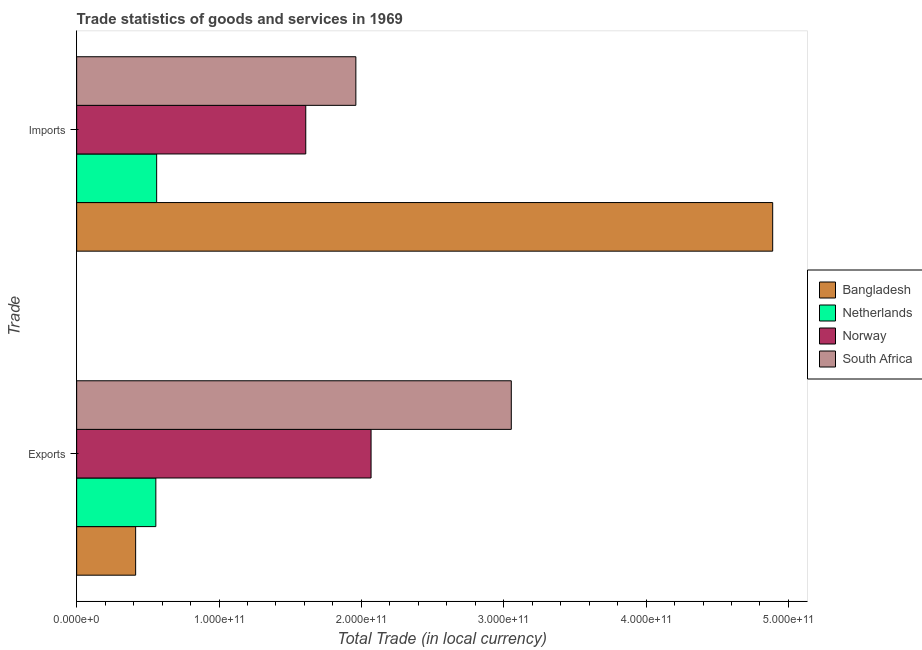How many different coloured bars are there?
Your answer should be compact. 4. What is the label of the 1st group of bars from the top?
Your response must be concise. Imports. What is the export of goods and services in Norway?
Keep it short and to the point. 2.07e+11. Across all countries, what is the maximum imports of goods and services?
Provide a short and direct response. 4.89e+11. Across all countries, what is the minimum imports of goods and services?
Your answer should be compact. 5.62e+1. In which country was the imports of goods and services maximum?
Keep it short and to the point. Bangladesh. In which country was the export of goods and services minimum?
Offer a terse response. Bangladesh. What is the total imports of goods and services in the graph?
Give a very brief answer. 9.02e+11. What is the difference between the imports of goods and services in Bangladesh and that in Netherlands?
Your response must be concise. 4.33e+11. What is the difference between the export of goods and services in Norway and the imports of goods and services in Bangladesh?
Your response must be concise. -2.82e+11. What is the average imports of goods and services per country?
Your response must be concise. 2.26e+11. What is the difference between the export of goods and services and imports of goods and services in Bangladesh?
Offer a very short reply. -4.48e+11. What is the ratio of the imports of goods and services in Norway to that in Netherlands?
Your answer should be very brief. 2.86. Is the export of goods and services in South Africa less than that in Bangladesh?
Keep it short and to the point. No. In how many countries, is the export of goods and services greater than the average export of goods and services taken over all countries?
Provide a short and direct response. 2. How many bars are there?
Give a very brief answer. 8. Are all the bars in the graph horizontal?
Your answer should be compact. Yes. What is the difference between two consecutive major ticks on the X-axis?
Make the answer very short. 1.00e+11. How many legend labels are there?
Your answer should be compact. 4. How are the legend labels stacked?
Your answer should be compact. Vertical. What is the title of the graph?
Your response must be concise. Trade statistics of goods and services in 1969. What is the label or title of the X-axis?
Your answer should be compact. Total Trade (in local currency). What is the label or title of the Y-axis?
Give a very brief answer. Trade. What is the Total Trade (in local currency) of Bangladesh in Exports?
Offer a very short reply. 4.14e+1. What is the Total Trade (in local currency) of Netherlands in Exports?
Give a very brief answer. 5.56e+1. What is the Total Trade (in local currency) in Norway in Exports?
Your answer should be very brief. 2.07e+11. What is the Total Trade (in local currency) of South Africa in Exports?
Provide a short and direct response. 3.05e+11. What is the Total Trade (in local currency) in Bangladesh in Imports?
Give a very brief answer. 4.89e+11. What is the Total Trade (in local currency) in Netherlands in Imports?
Ensure brevity in your answer.  5.62e+1. What is the Total Trade (in local currency) in Norway in Imports?
Ensure brevity in your answer.  1.61e+11. What is the Total Trade (in local currency) of South Africa in Imports?
Your response must be concise. 1.96e+11. Across all Trade, what is the maximum Total Trade (in local currency) of Bangladesh?
Provide a short and direct response. 4.89e+11. Across all Trade, what is the maximum Total Trade (in local currency) in Netherlands?
Offer a very short reply. 5.62e+1. Across all Trade, what is the maximum Total Trade (in local currency) in Norway?
Your answer should be compact. 2.07e+11. Across all Trade, what is the maximum Total Trade (in local currency) in South Africa?
Your answer should be very brief. 3.05e+11. Across all Trade, what is the minimum Total Trade (in local currency) of Bangladesh?
Ensure brevity in your answer.  4.14e+1. Across all Trade, what is the minimum Total Trade (in local currency) in Netherlands?
Give a very brief answer. 5.56e+1. Across all Trade, what is the minimum Total Trade (in local currency) of Norway?
Keep it short and to the point. 1.61e+11. Across all Trade, what is the minimum Total Trade (in local currency) in South Africa?
Your answer should be compact. 1.96e+11. What is the total Total Trade (in local currency) in Bangladesh in the graph?
Keep it short and to the point. 5.30e+11. What is the total Total Trade (in local currency) of Netherlands in the graph?
Your answer should be very brief. 1.12e+11. What is the total Total Trade (in local currency) of Norway in the graph?
Ensure brevity in your answer.  3.68e+11. What is the total Total Trade (in local currency) in South Africa in the graph?
Give a very brief answer. 5.01e+11. What is the difference between the Total Trade (in local currency) of Bangladesh in Exports and that in Imports?
Provide a short and direct response. -4.48e+11. What is the difference between the Total Trade (in local currency) of Netherlands in Exports and that in Imports?
Your answer should be very brief. -5.76e+08. What is the difference between the Total Trade (in local currency) of Norway in Exports and that in Imports?
Offer a very short reply. 4.59e+1. What is the difference between the Total Trade (in local currency) in South Africa in Exports and that in Imports?
Your answer should be very brief. 1.09e+11. What is the difference between the Total Trade (in local currency) in Bangladesh in Exports and the Total Trade (in local currency) in Netherlands in Imports?
Offer a very short reply. -1.48e+1. What is the difference between the Total Trade (in local currency) of Bangladesh in Exports and the Total Trade (in local currency) of Norway in Imports?
Give a very brief answer. -1.20e+11. What is the difference between the Total Trade (in local currency) in Bangladesh in Exports and the Total Trade (in local currency) in South Africa in Imports?
Give a very brief answer. -1.55e+11. What is the difference between the Total Trade (in local currency) in Netherlands in Exports and the Total Trade (in local currency) in Norway in Imports?
Keep it short and to the point. -1.05e+11. What is the difference between the Total Trade (in local currency) in Netherlands in Exports and the Total Trade (in local currency) in South Africa in Imports?
Give a very brief answer. -1.41e+11. What is the difference between the Total Trade (in local currency) of Norway in Exports and the Total Trade (in local currency) of South Africa in Imports?
Keep it short and to the point. 1.07e+1. What is the average Total Trade (in local currency) of Bangladesh per Trade?
Provide a short and direct response. 2.65e+11. What is the average Total Trade (in local currency) of Netherlands per Trade?
Your answer should be compact. 5.59e+1. What is the average Total Trade (in local currency) of Norway per Trade?
Your answer should be very brief. 1.84e+11. What is the average Total Trade (in local currency) of South Africa per Trade?
Give a very brief answer. 2.51e+11. What is the difference between the Total Trade (in local currency) of Bangladesh and Total Trade (in local currency) of Netherlands in Exports?
Give a very brief answer. -1.42e+1. What is the difference between the Total Trade (in local currency) in Bangladesh and Total Trade (in local currency) in Norway in Exports?
Your answer should be compact. -1.65e+11. What is the difference between the Total Trade (in local currency) in Bangladesh and Total Trade (in local currency) in South Africa in Exports?
Provide a short and direct response. -2.64e+11. What is the difference between the Total Trade (in local currency) in Netherlands and Total Trade (in local currency) in Norway in Exports?
Ensure brevity in your answer.  -1.51e+11. What is the difference between the Total Trade (in local currency) of Netherlands and Total Trade (in local currency) of South Africa in Exports?
Give a very brief answer. -2.50e+11. What is the difference between the Total Trade (in local currency) in Norway and Total Trade (in local currency) in South Africa in Exports?
Give a very brief answer. -9.85e+1. What is the difference between the Total Trade (in local currency) in Bangladesh and Total Trade (in local currency) in Netherlands in Imports?
Your answer should be very brief. 4.33e+11. What is the difference between the Total Trade (in local currency) of Bangladesh and Total Trade (in local currency) of Norway in Imports?
Give a very brief answer. 3.28e+11. What is the difference between the Total Trade (in local currency) in Bangladesh and Total Trade (in local currency) in South Africa in Imports?
Offer a very short reply. 2.93e+11. What is the difference between the Total Trade (in local currency) of Netherlands and Total Trade (in local currency) of Norway in Imports?
Your response must be concise. -1.05e+11. What is the difference between the Total Trade (in local currency) of Netherlands and Total Trade (in local currency) of South Africa in Imports?
Give a very brief answer. -1.40e+11. What is the difference between the Total Trade (in local currency) of Norway and Total Trade (in local currency) of South Africa in Imports?
Provide a short and direct response. -3.52e+1. What is the ratio of the Total Trade (in local currency) of Bangladesh in Exports to that in Imports?
Your response must be concise. 0.08. What is the ratio of the Total Trade (in local currency) in Netherlands in Exports to that in Imports?
Your answer should be compact. 0.99. What is the ratio of the Total Trade (in local currency) in Norway in Exports to that in Imports?
Your response must be concise. 1.28. What is the ratio of the Total Trade (in local currency) in South Africa in Exports to that in Imports?
Your answer should be compact. 1.56. What is the difference between the highest and the second highest Total Trade (in local currency) of Bangladesh?
Ensure brevity in your answer.  4.48e+11. What is the difference between the highest and the second highest Total Trade (in local currency) of Netherlands?
Offer a very short reply. 5.76e+08. What is the difference between the highest and the second highest Total Trade (in local currency) in Norway?
Provide a succinct answer. 4.59e+1. What is the difference between the highest and the second highest Total Trade (in local currency) of South Africa?
Ensure brevity in your answer.  1.09e+11. What is the difference between the highest and the lowest Total Trade (in local currency) in Bangladesh?
Provide a succinct answer. 4.48e+11. What is the difference between the highest and the lowest Total Trade (in local currency) of Netherlands?
Offer a terse response. 5.76e+08. What is the difference between the highest and the lowest Total Trade (in local currency) of Norway?
Provide a short and direct response. 4.59e+1. What is the difference between the highest and the lowest Total Trade (in local currency) in South Africa?
Provide a succinct answer. 1.09e+11. 